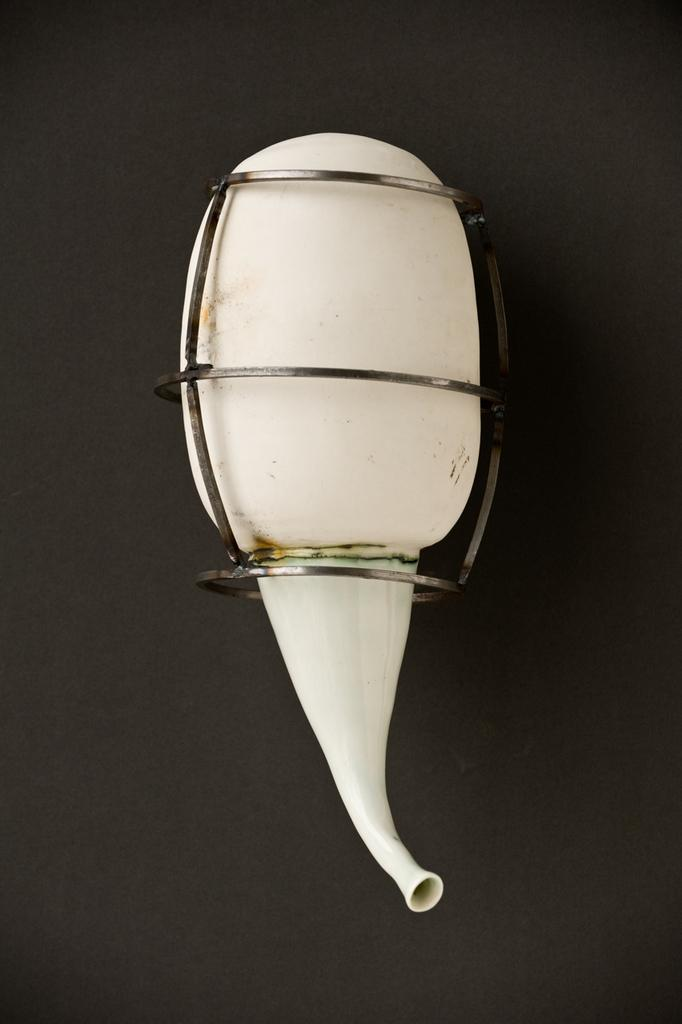What is the color of the object in the image? The object in the image is white. What is the color of the surface on which the object is placed? The surface is black. Is the object's dad present in the image? There is no information about the object's dad in the image, as it only shows a white object on a black surface. 